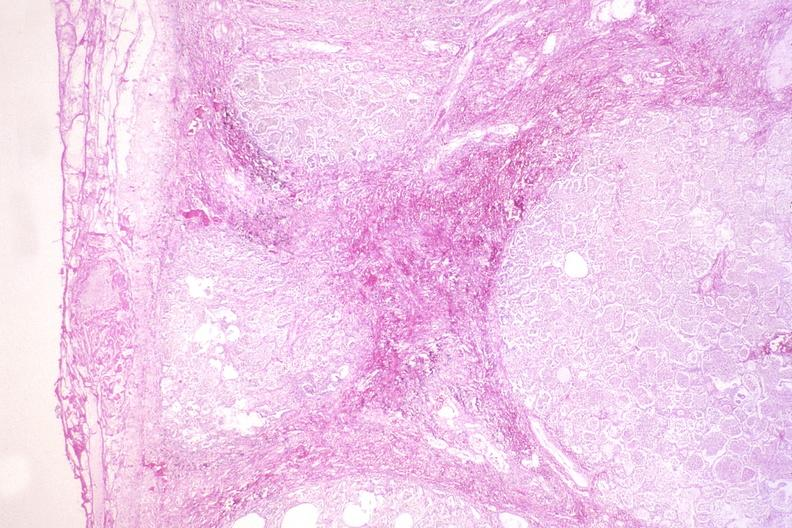does this image show kaposis 's sarcoma in the lung?
Answer the question using a single word or phrase. Yes 